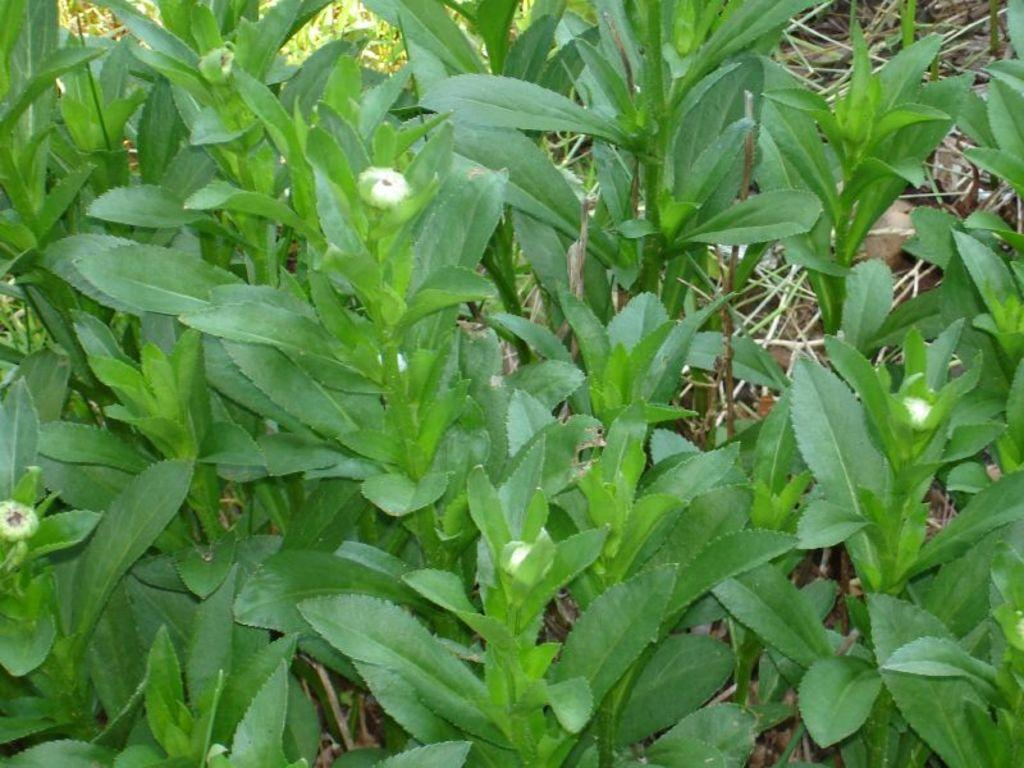What type of vegetation can be seen in the image? There are plants in the image, including flower buds and green leaves. Can you describe any specific features of the plants? Yes, there are flower buds and green leaves visible. What can be seen in the background of the image? There are dry leaves and twigs in the background of the image. What account number is associated with the airplane in the image? There is no airplane present in the image, and therefore no account number can be associated with it. 